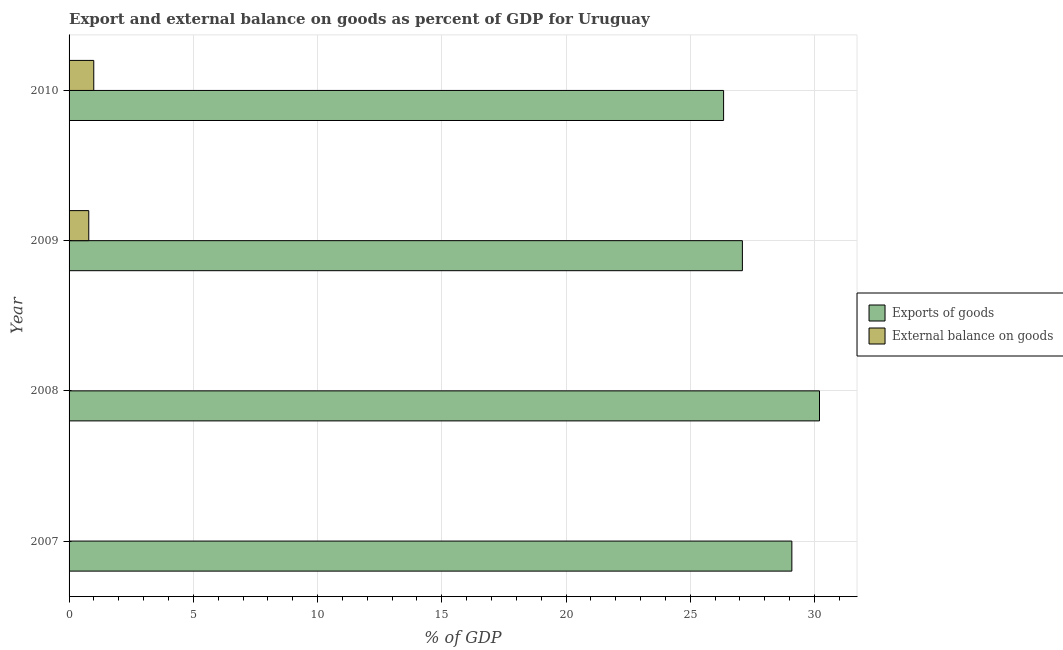How many different coloured bars are there?
Offer a terse response. 2. How many bars are there on the 2nd tick from the top?
Make the answer very short. 2. How many bars are there on the 3rd tick from the bottom?
Keep it short and to the point. 2. What is the label of the 1st group of bars from the top?
Provide a short and direct response. 2010. In how many cases, is the number of bars for a given year not equal to the number of legend labels?
Your answer should be very brief. 2. What is the export of goods as percentage of gdp in 2007?
Make the answer very short. 29.09. Across all years, what is the maximum external balance on goods as percentage of gdp?
Your response must be concise. 0.99. What is the total export of goods as percentage of gdp in the graph?
Offer a very short reply. 112.74. What is the difference between the export of goods as percentage of gdp in 2008 and that in 2009?
Your answer should be compact. 3.1. What is the difference between the export of goods as percentage of gdp in 2008 and the external balance on goods as percentage of gdp in 2007?
Offer a very short reply. 30.2. What is the average external balance on goods as percentage of gdp per year?
Offer a terse response. 0.45. In the year 2009, what is the difference between the export of goods as percentage of gdp and external balance on goods as percentage of gdp?
Provide a succinct answer. 26.31. What is the ratio of the export of goods as percentage of gdp in 2008 to that in 2010?
Offer a terse response. 1.15. Is the export of goods as percentage of gdp in 2009 less than that in 2010?
Your answer should be very brief. No. What is the difference between the highest and the second highest export of goods as percentage of gdp?
Offer a terse response. 1.11. What is the difference between the highest and the lowest export of goods as percentage of gdp?
Your answer should be compact. 3.86. Are all the bars in the graph horizontal?
Your answer should be very brief. Yes. How many years are there in the graph?
Your answer should be very brief. 4. What is the difference between two consecutive major ticks on the X-axis?
Your answer should be very brief. 5. How are the legend labels stacked?
Your answer should be compact. Vertical. What is the title of the graph?
Ensure brevity in your answer.  Export and external balance on goods as percent of GDP for Uruguay. What is the label or title of the X-axis?
Provide a short and direct response. % of GDP. What is the label or title of the Y-axis?
Make the answer very short. Year. What is the % of GDP in Exports of goods in 2007?
Make the answer very short. 29.09. What is the % of GDP in External balance on goods in 2007?
Your answer should be very brief. 0. What is the % of GDP in Exports of goods in 2008?
Provide a short and direct response. 30.2. What is the % of GDP of External balance on goods in 2008?
Make the answer very short. 0. What is the % of GDP of Exports of goods in 2009?
Offer a terse response. 27.1. What is the % of GDP of External balance on goods in 2009?
Give a very brief answer. 0.79. What is the % of GDP of Exports of goods in 2010?
Provide a short and direct response. 26.34. What is the % of GDP in External balance on goods in 2010?
Offer a very short reply. 0.99. Across all years, what is the maximum % of GDP in Exports of goods?
Provide a short and direct response. 30.2. Across all years, what is the maximum % of GDP of External balance on goods?
Keep it short and to the point. 0.99. Across all years, what is the minimum % of GDP in Exports of goods?
Offer a very short reply. 26.34. Across all years, what is the minimum % of GDP in External balance on goods?
Ensure brevity in your answer.  0. What is the total % of GDP in Exports of goods in the graph?
Offer a very short reply. 112.74. What is the total % of GDP of External balance on goods in the graph?
Offer a terse response. 1.79. What is the difference between the % of GDP in Exports of goods in 2007 and that in 2008?
Provide a succinct answer. -1.11. What is the difference between the % of GDP in Exports of goods in 2007 and that in 2009?
Provide a succinct answer. 1.99. What is the difference between the % of GDP of Exports of goods in 2007 and that in 2010?
Your response must be concise. 2.75. What is the difference between the % of GDP in Exports of goods in 2008 and that in 2009?
Offer a very short reply. 3.1. What is the difference between the % of GDP in Exports of goods in 2008 and that in 2010?
Provide a succinct answer. 3.86. What is the difference between the % of GDP in Exports of goods in 2009 and that in 2010?
Your response must be concise. 0.76. What is the difference between the % of GDP of External balance on goods in 2009 and that in 2010?
Give a very brief answer. -0.2. What is the difference between the % of GDP in Exports of goods in 2007 and the % of GDP in External balance on goods in 2009?
Your response must be concise. 28.3. What is the difference between the % of GDP of Exports of goods in 2007 and the % of GDP of External balance on goods in 2010?
Give a very brief answer. 28.1. What is the difference between the % of GDP in Exports of goods in 2008 and the % of GDP in External balance on goods in 2009?
Make the answer very short. 29.41. What is the difference between the % of GDP of Exports of goods in 2008 and the % of GDP of External balance on goods in 2010?
Make the answer very short. 29.21. What is the difference between the % of GDP of Exports of goods in 2009 and the % of GDP of External balance on goods in 2010?
Give a very brief answer. 26.11. What is the average % of GDP in Exports of goods per year?
Ensure brevity in your answer.  28.18. What is the average % of GDP of External balance on goods per year?
Your answer should be compact. 0.45. In the year 2009, what is the difference between the % of GDP in Exports of goods and % of GDP in External balance on goods?
Offer a very short reply. 26.31. In the year 2010, what is the difference between the % of GDP of Exports of goods and % of GDP of External balance on goods?
Ensure brevity in your answer.  25.35. What is the ratio of the % of GDP in Exports of goods in 2007 to that in 2008?
Keep it short and to the point. 0.96. What is the ratio of the % of GDP in Exports of goods in 2007 to that in 2009?
Ensure brevity in your answer.  1.07. What is the ratio of the % of GDP of Exports of goods in 2007 to that in 2010?
Offer a terse response. 1.1. What is the ratio of the % of GDP in Exports of goods in 2008 to that in 2009?
Offer a terse response. 1.11. What is the ratio of the % of GDP of Exports of goods in 2008 to that in 2010?
Make the answer very short. 1.15. What is the ratio of the % of GDP of Exports of goods in 2009 to that in 2010?
Give a very brief answer. 1.03. What is the ratio of the % of GDP of External balance on goods in 2009 to that in 2010?
Keep it short and to the point. 0.8. What is the difference between the highest and the second highest % of GDP of Exports of goods?
Your answer should be compact. 1.11. What is the difference between the highest and the lowest % of GDP in Exports of goods?
Provide a succinct answer. 3.86. What is the difference between the highest and the lowest % of GDP in External balance on goods?
Ensure brevity in your answer.  0.99. 